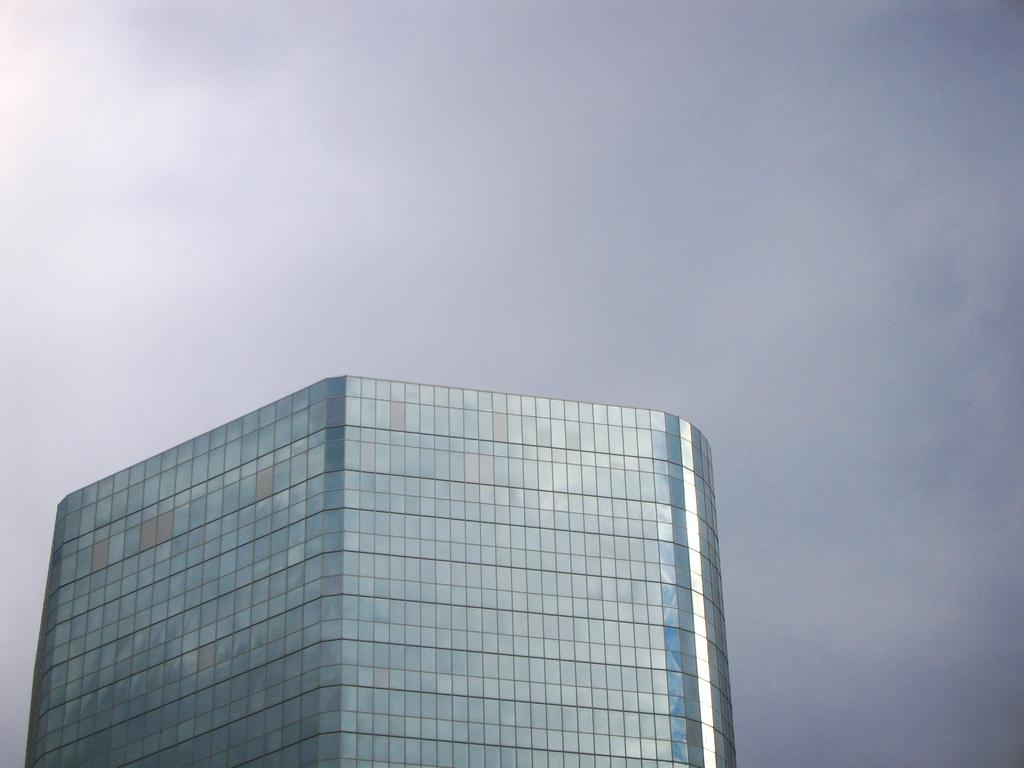What type of structure is present in the image? There is a building in the image. What materials are used to construct the building? The building is made up of glass and blue panels. What can be seen in the background of the image? The sky is visible at the top of the image. How many pizzas are being delivered to the building in the image? There is no indication of pizzas or a delivery in the image. 